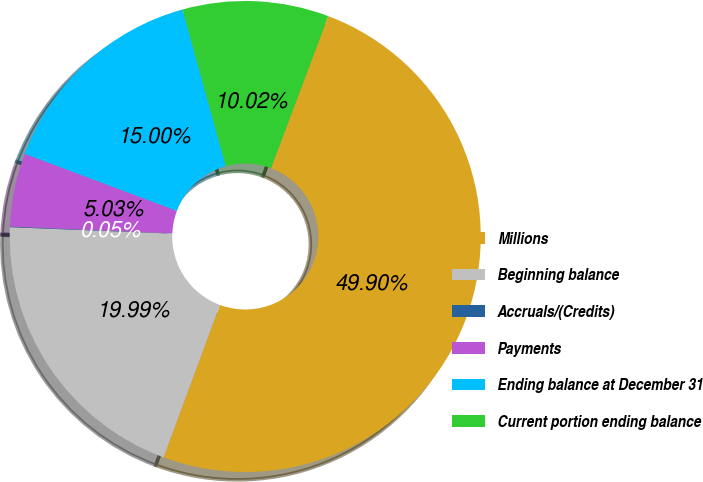Convert chart. <chart><loc_0><loc_0><loc_500><loc_500><pie_chart><fcel>Millions<fcel>Beginning balance<fcel>Accruals/(Credits)<fcel>Payments<fcel>Ending balance at December 31<fcel>Current portion ending balance<nl><fcel>49.9%<fcel>19.99%<fcel>0.05%<fcel>5.03%<fcel>15.0%<fcel>10.02%<nl></chart> 